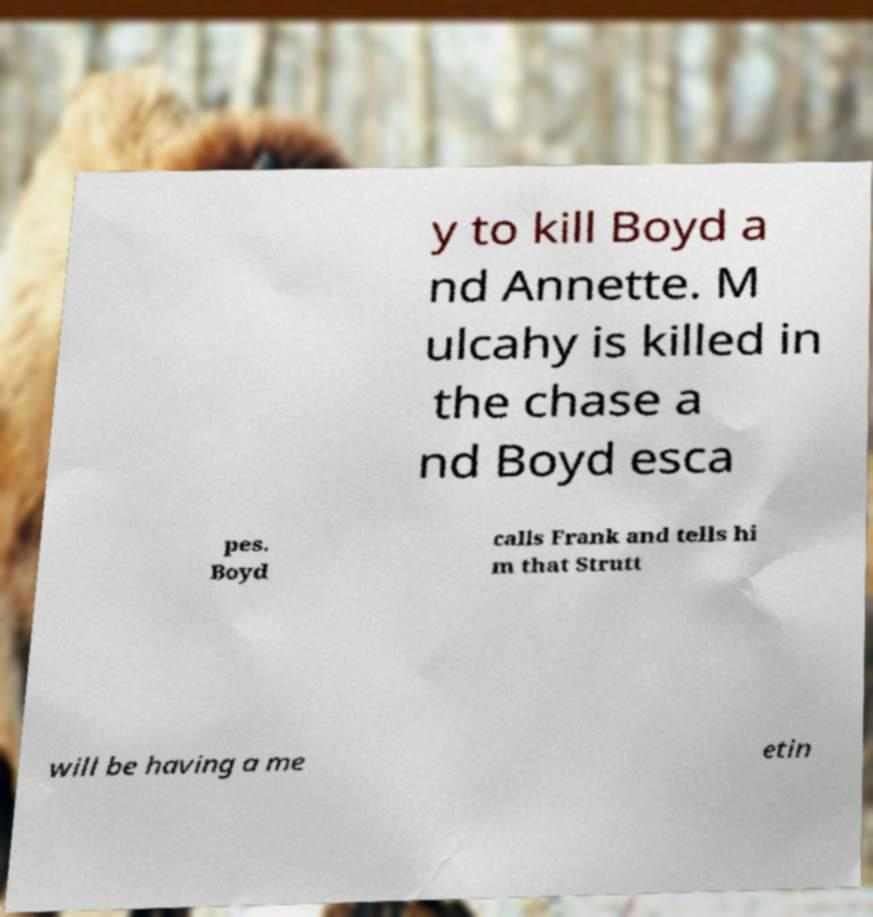What messages or text are displayed in this image? I need them in a readable, typed format. y to kill Boyd a nd Annette. M ulcahy is killed in the chase a nd Boyd esca pes. Boyd calls Frank and tells hi m that Strutt will be having a me etin 